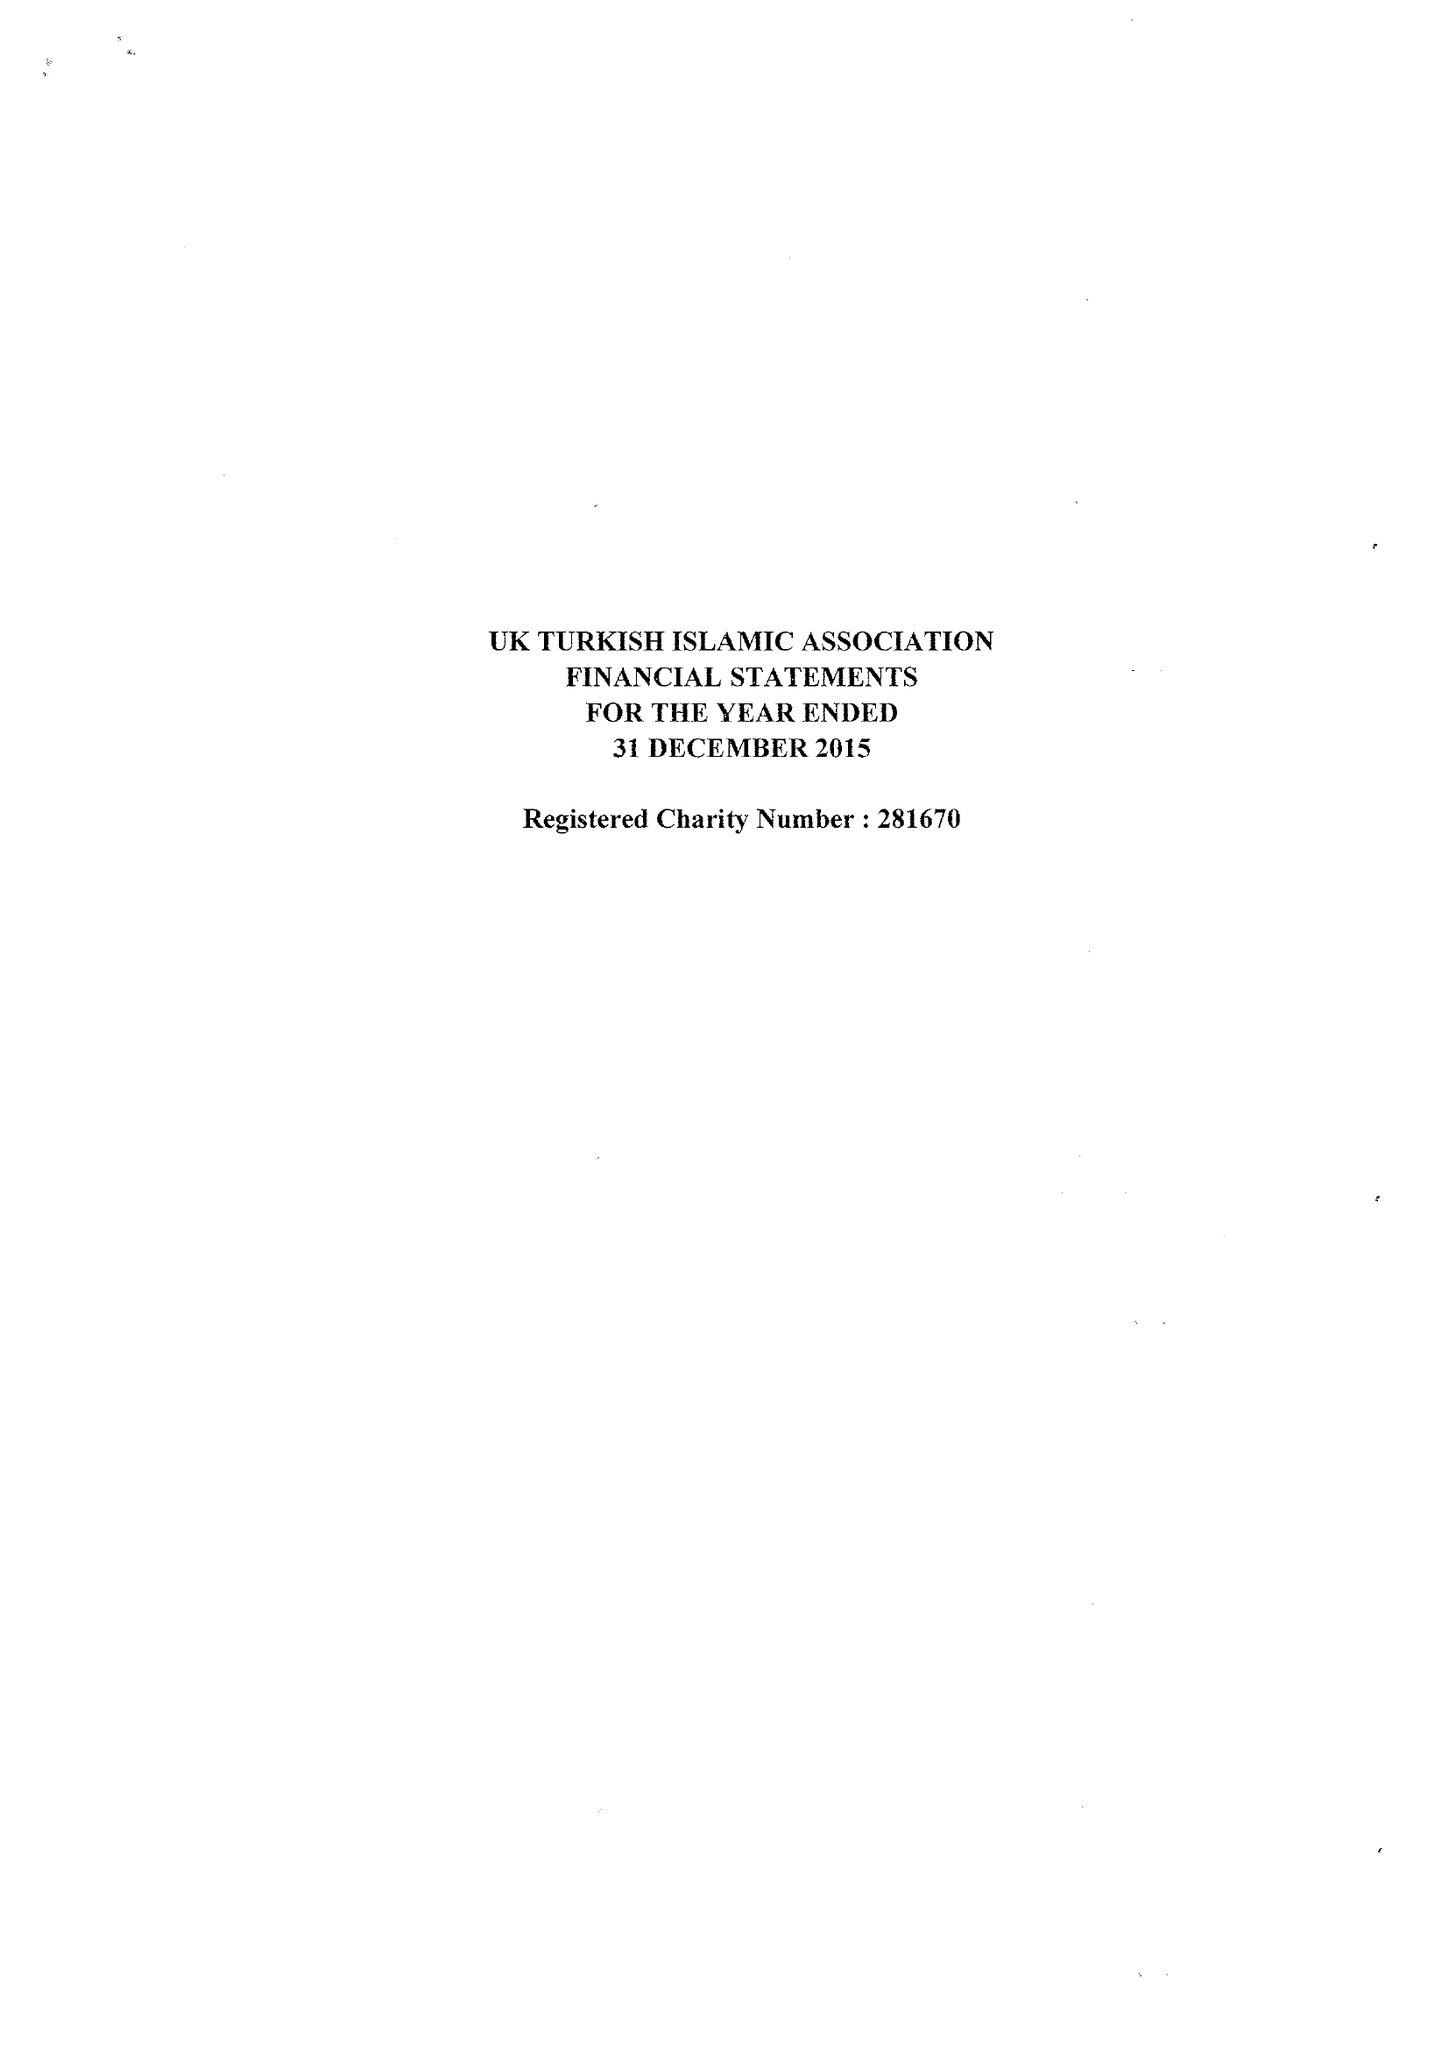What is the value for the income_annually_in_british_pounds?
Answer the question using a single word or phrase. 124531.00 